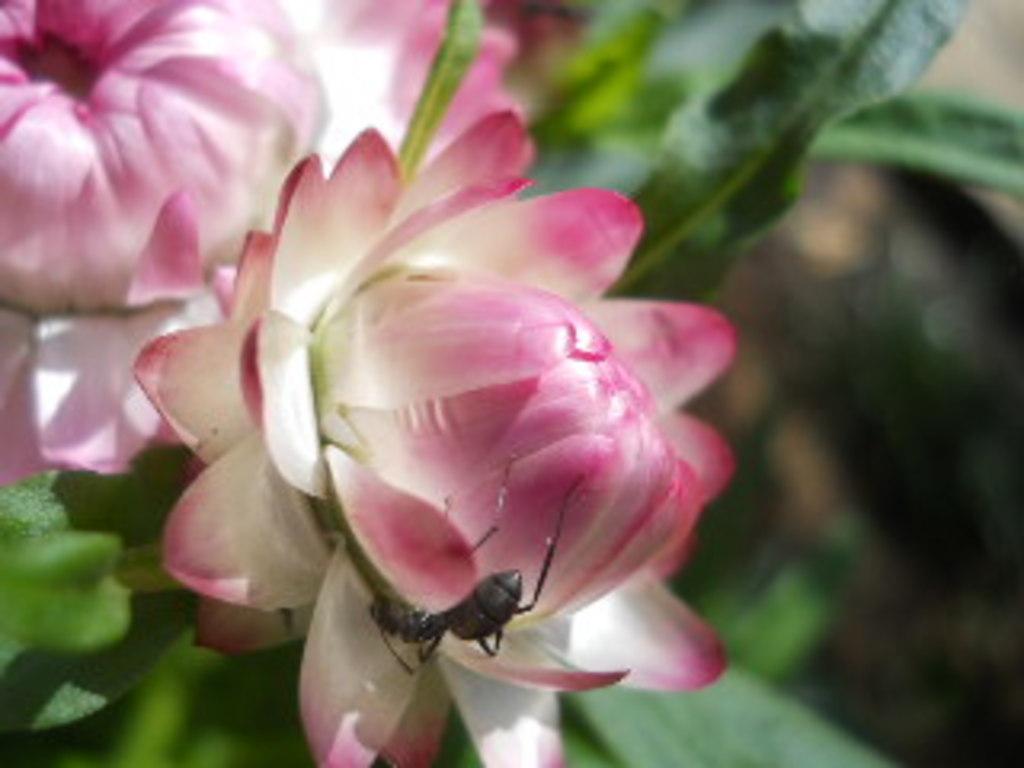Describe this image in one or two sentences. In this image I can see the flowers to the plants. These flowers are in white and pink color. I can see an insect on the flower. 